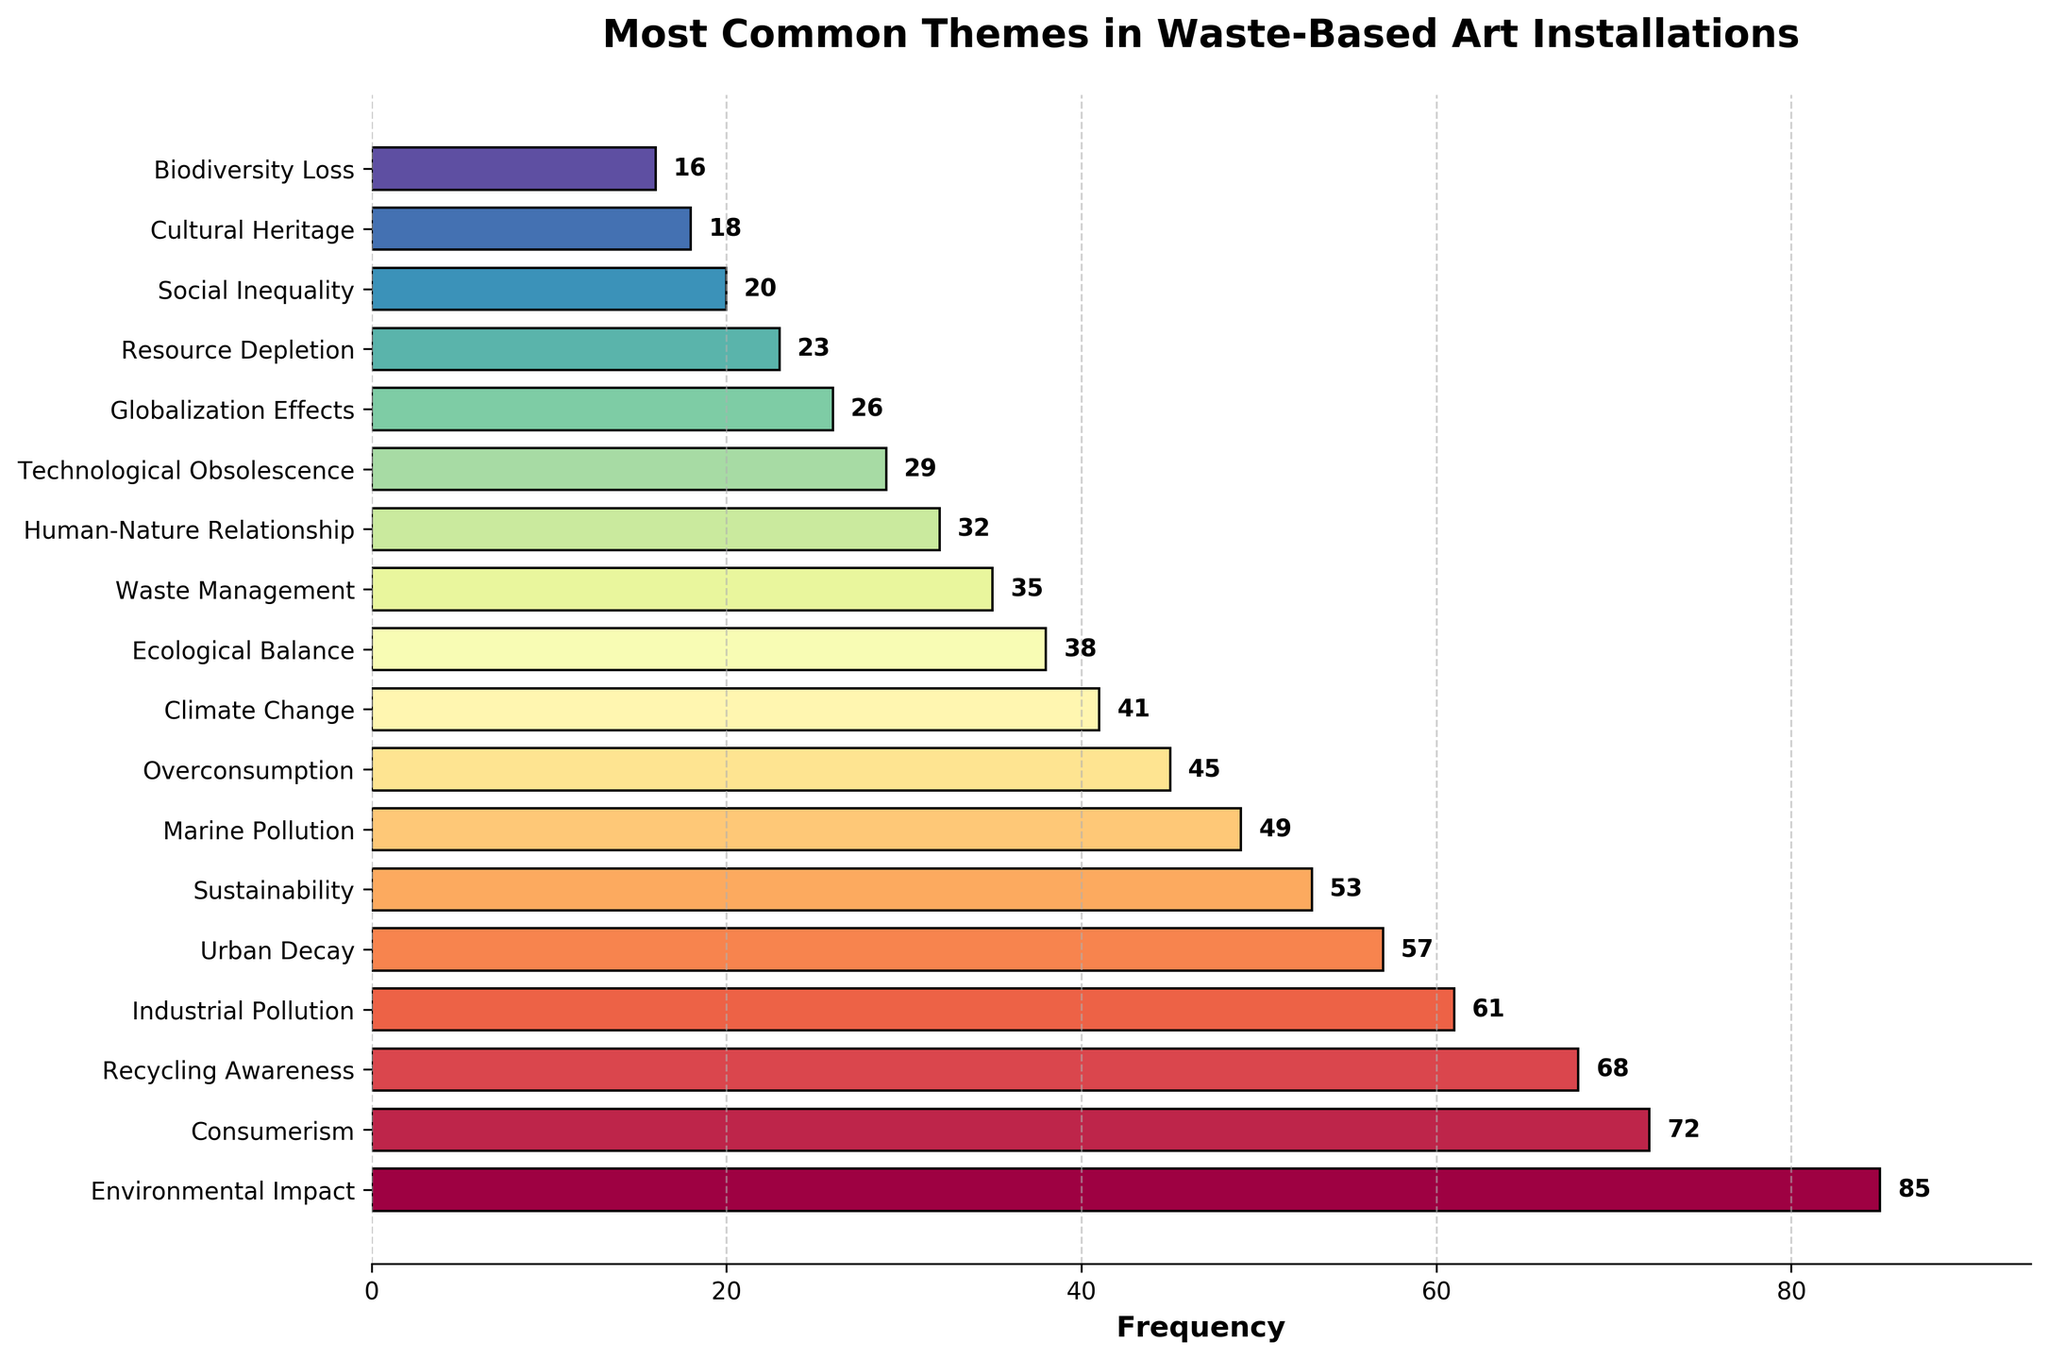What theme has the highest frequency in the waste-based art installations? According to the bar chart, the theme with the highest frequency is 'Environmental Impact' with a frequency of 85.
Answer: Environmental Impact How many themes have a frequency greater than or equal to 50? Count the number of themes with frequencies of 50 or higher. They are Environmental Impact, Consumerism, Recycling Awareness, Industrial Pollution, Urban Decay, and Sustainability. This totals to 6 themes.
Answer: 6 Which theme has a frequency just below 'Environmental Impact'? The frequency just below 'Environmental Impact' (85) is 'Consumerism' with a frequency of 72.
Answer: Consumerism What is the combined frequency of 'Marine Pollution' and 'Urban Decay' themes? Add the frequencies of 'Marine Pollution' (49) and 'Urban Decay' (57). The combined total is 49 + 57 = 106.
Answer: 106 Which two themes have the lowest recorded frequencies and what are they? Identify the two themes with the lowest frequencies, which are 'Biodiversity Loss' with 16 and 'Cultural Heritage' with 18.
Answer: Biodiversity Loss and Cultural Heritage Is 'Sustainability' more frequently explored than 'Climate Change'? According to the chart, 'Sustainability' has a frequency of 53 while 'Climate Change' has a frequency of 41. Therefore, 'Sustainability' is more frequently explored.
Answer: Yes How much higher is the frequency of 'Recycling Awareness' compared to 'Waste Management'? Subtract the frequency of 'Waste Management' (35) from 'Recycling Awareness' (68). The difference is 68 - 35 = 33.
Answer: 33 What is the average frequency of the themes 'Technological Obsolescence,' 'Globalization Effects,' and 'Resource Depletion'? Add the frequencies of these themes (29 + 26 + 23) and divide by 3. The average is (29 + 26 + 23) / 3 = 26.
Answer: 26 Which theme is represented by the halfway point (median) if you list all frequencies in ascending order? When the frequencies are listed in ascending order, the median is the middle value. Here, the median value falls on 'Overconsumption' with a frequency of 45.
Answer: Overconsumption What visual feature helps indicate the frequency values of each bar on the chart? Each bar has a textual label next to it indicating its specific frequency value, aiding in quick identification of the values.
Answer: Text labels 